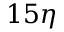<formula> <loc_0><loc_0><loc_500><loc_500>1 5 \eta</formula> 